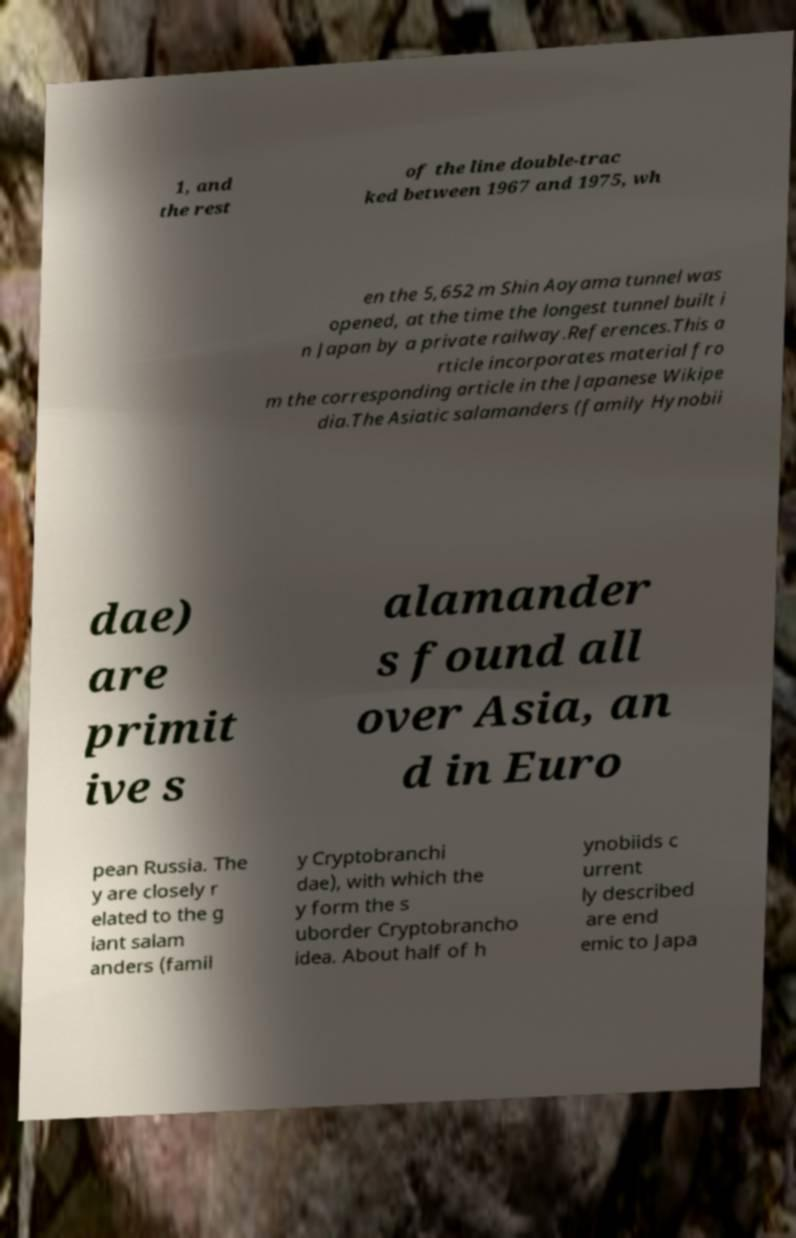There's text embedded in this image that I need extracted. Can you transcribe it verbatim? 1, and the rest of the line double-trac ked between 1967 and 1975, wh en the 5,652 m Shin Aoyama tunnel was opened, at the time the longest tunnel built i n Japan by a private railway.References.This a rticle incorporates material fro m the corresponding article in the Japanese Wikipe dia.The Asiatic salamanders (family Hynobii dae) are primit ive s alamander s found all over Asia, an d in Euro pean Russia. The y are closely r elated to the g iant salam anders (famil y Cryptobranchi dae), with which the y form the s uborder Cryptobrancho idea. About half of h ynobiids c urrent ly described are end emic to Japa 